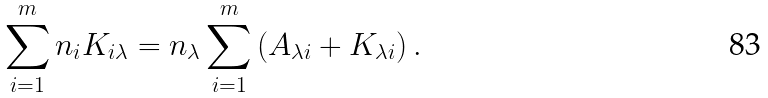<formula> <loc_0><loc_0><loc_500><loc_500>\sum _ { i = 1 } ^ { m } n _ { i } K _ { i \lambda } = n _ { \lambda } \sum _ { i = 1 } ^ { m } \left ( A _ { \lambda i } + K _ { \lambda i } \right ) .</formula> 